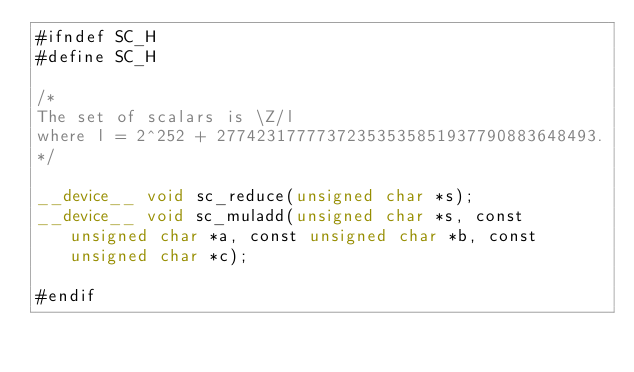<code> <loc_0><loc_0><loc_500><loc_500><_Cuda_>#ifndef SC_H
#define SC_H

/*
The set of scalars is \Z/l
where l = 2^252 + 27742317777372353535851937790883648493.
*/

__device__ void sc_reduce(unsigned char *s);
__device__ void sc_muladd(unsigned char *s, const unsigned char *a, const unsigned char *b, const unsigned char *c);

#endif
</code> 